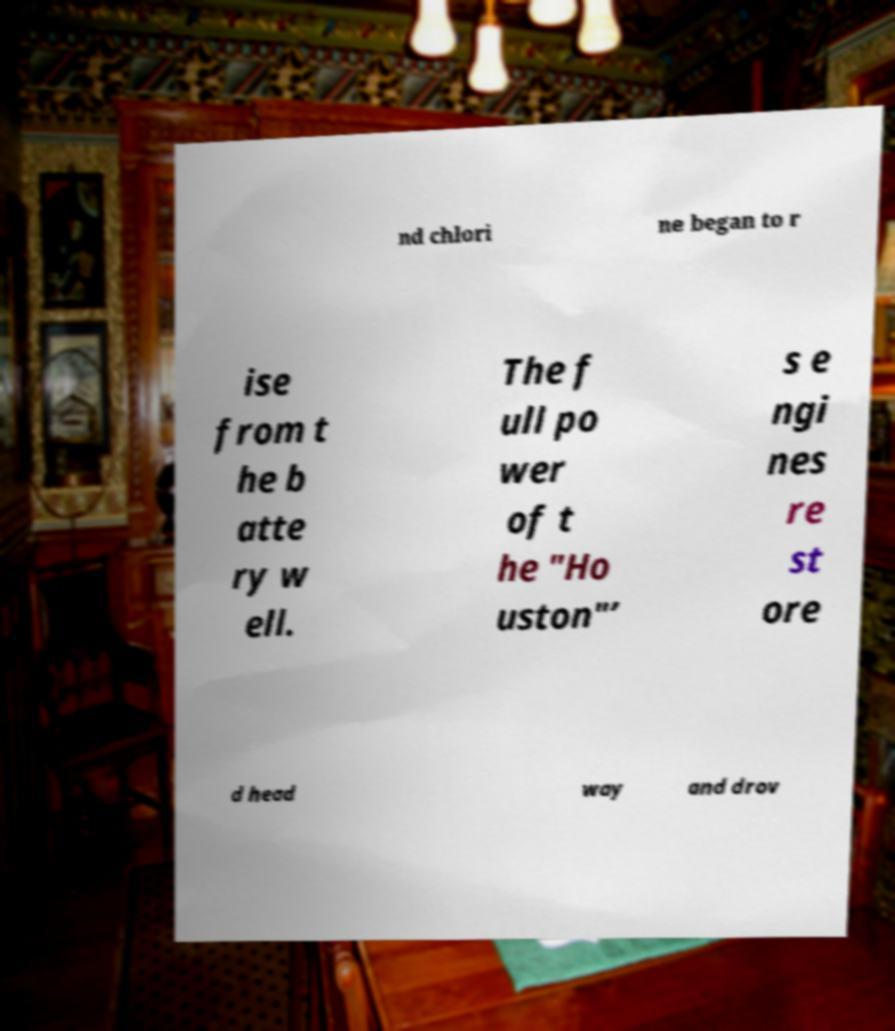Could you extract and type out the text from this image? nd chlori ne began to r ise from t he b atte ry w ell. The f ull po wer of t he "Ho uston"’ s e ngi nes re st ore d head way and drov 